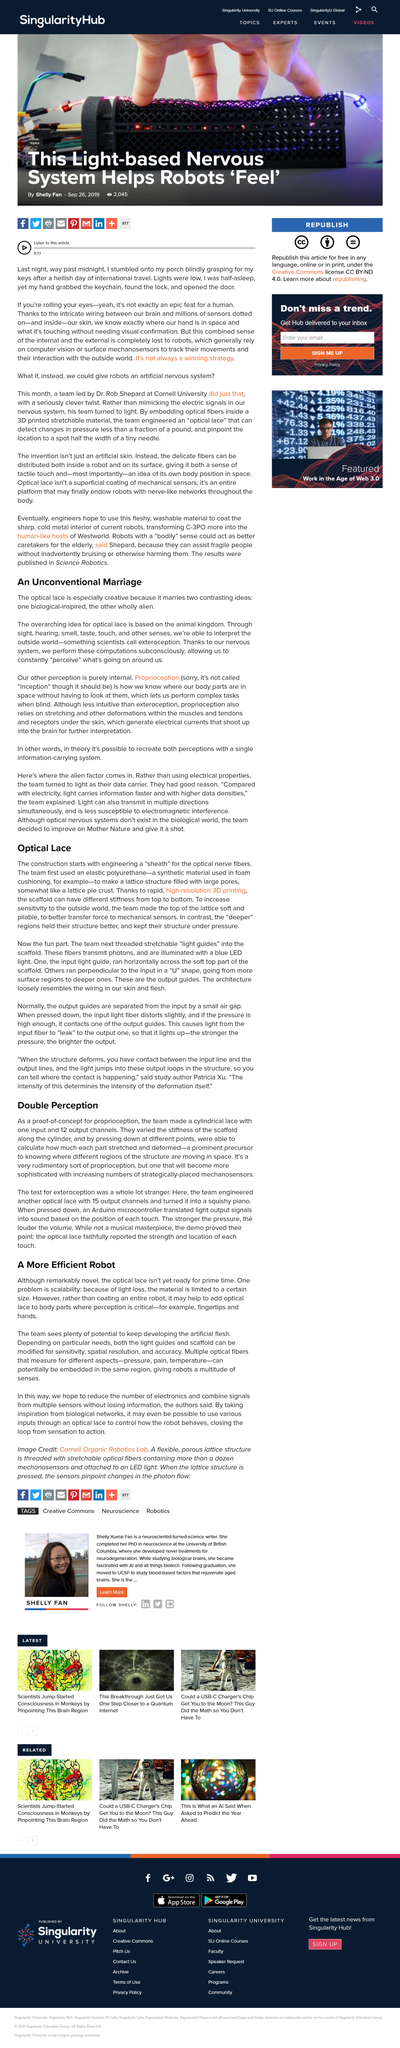Mention a couple of crucial points in this snapshot. The Optical Lace uses mechanical sensors to detect force. The optical lace is not yet ready for mass adoption as its scalability is limited by light loss, resulting in a maximum size it can handle. The light guides and scaffold can be modified for improved sensitivity, spatial resolution, and accuracy in optical detection of targets. The team increased the sensitivity of the Optical Lace to the outside world by making the top of the lattice "sheath" soft and pliable. The optical lace combines two distinct ideas: one that is inspired by biology and the other that is wholly alien in nature. 